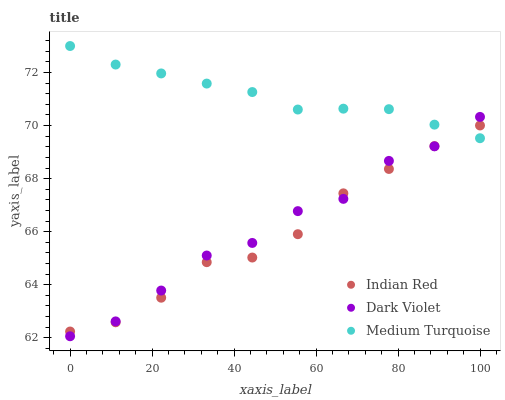Does Indian Red have the minimum area under the curve?
Answer yes or no. Yes. Does Medium Turquoise have the maximum area under the curve?
Answer yes or no. Yes. Does Dark Violet have the minimum area under the curve?
Answer yes or no. No. Does Dark Violet have the maximum area under the curve?
Answer yes or no. No. Is Medium Turquoise the smoothest?
Answer yes or no. Yes. Is Dark Violet the roughest?
Answer yes or no. Yes. Is Indian Red the smoothest?
Answer yes or no. No. Is Indian Red the roughest?
Answer yes or no. No. Does Dark Violet have the lowest value?
Answer yes or no. Yes. Does Indian Red have the lowest value?
Answer yes or no. No. Does Medium Turquoise have the highest value?
Answer yes or no. Yes. Does Dark Violet have the highest value?
Answer yes or no. No. Does Dark Violet intersect Indian Red?
Answer yes or no. Yes. Is Dark Violet less than Indian Red?
Answer yes or no. No. Is Dark Violet greater than Indian Red?
Answer yes or no. No. 